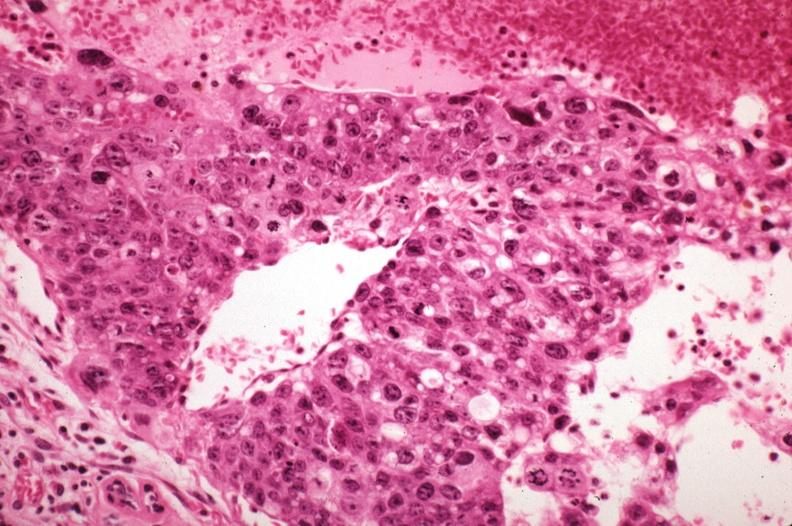what is present?
Answer the question using a single word or phrase. Breast 